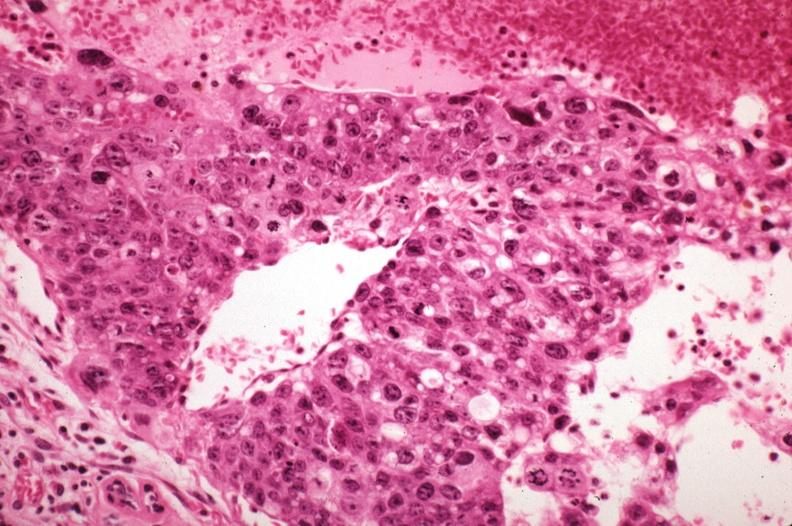what is present?
Answer the question using a single word or phrase. Breast 